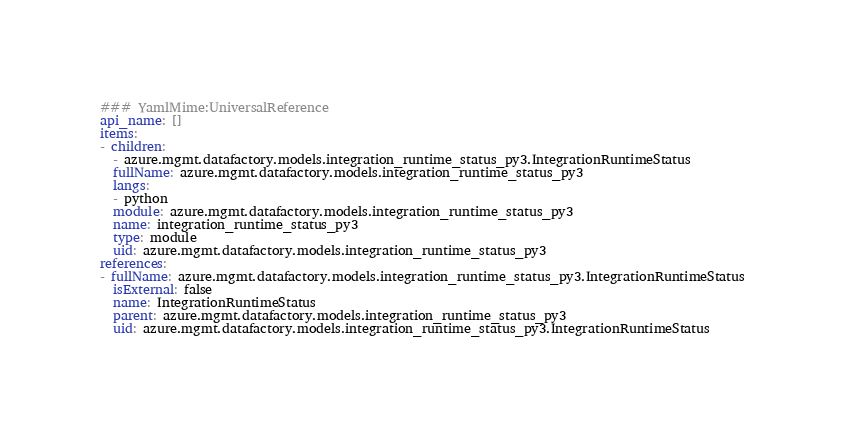<code> <loc_0><loc_0><loc_500><loc_500><_YAML_>### YamlMime:UniversalReference
api_name: []
items:
- children:
  - azure.mgmt.datafactory.models.integration_runtime_status_py3.IntegrationRuntimeStatus
  fullName: azure.mgmt.datafactory.models.integration_runtime_status_py3
  langs:
  - python
  module: azure.mgmt.datafactory.models.integration_runtime_status_py3
  name: integration_runtime_status_py3
  type: module
  uid: azure.mgmt.datafactory.models.integration_runtime_status_py3
references:
- fullName: azure.mgmt.datafactory.models.integration_runtime_status_py3.IntegrationRuntimeStatus
  isExternal: false
  name: IntegrationRuntimeStatus
  parent: azure.mgmt.datafactory.models.integration_runtime_status_py3
  uid: azure.mgmt.datafactory.models.integration_runtime_status_py3.IntegrationRuntimeStatus
</code> 